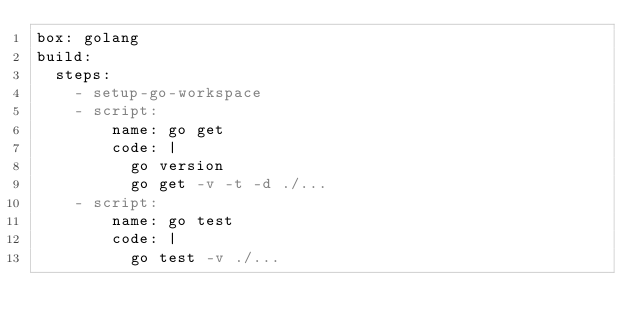Convert code to text. <code><loc_0><loc_0><loc_500><loc_500><_YAML_>box: golang
build:
  steps:
    - setup-go-workspace
    - script:
        name: go get
        code: |
          go version
          go get -v -t -d ./...
    - script:
        name: go test
        code: |
          go test -v ./...
</code> 